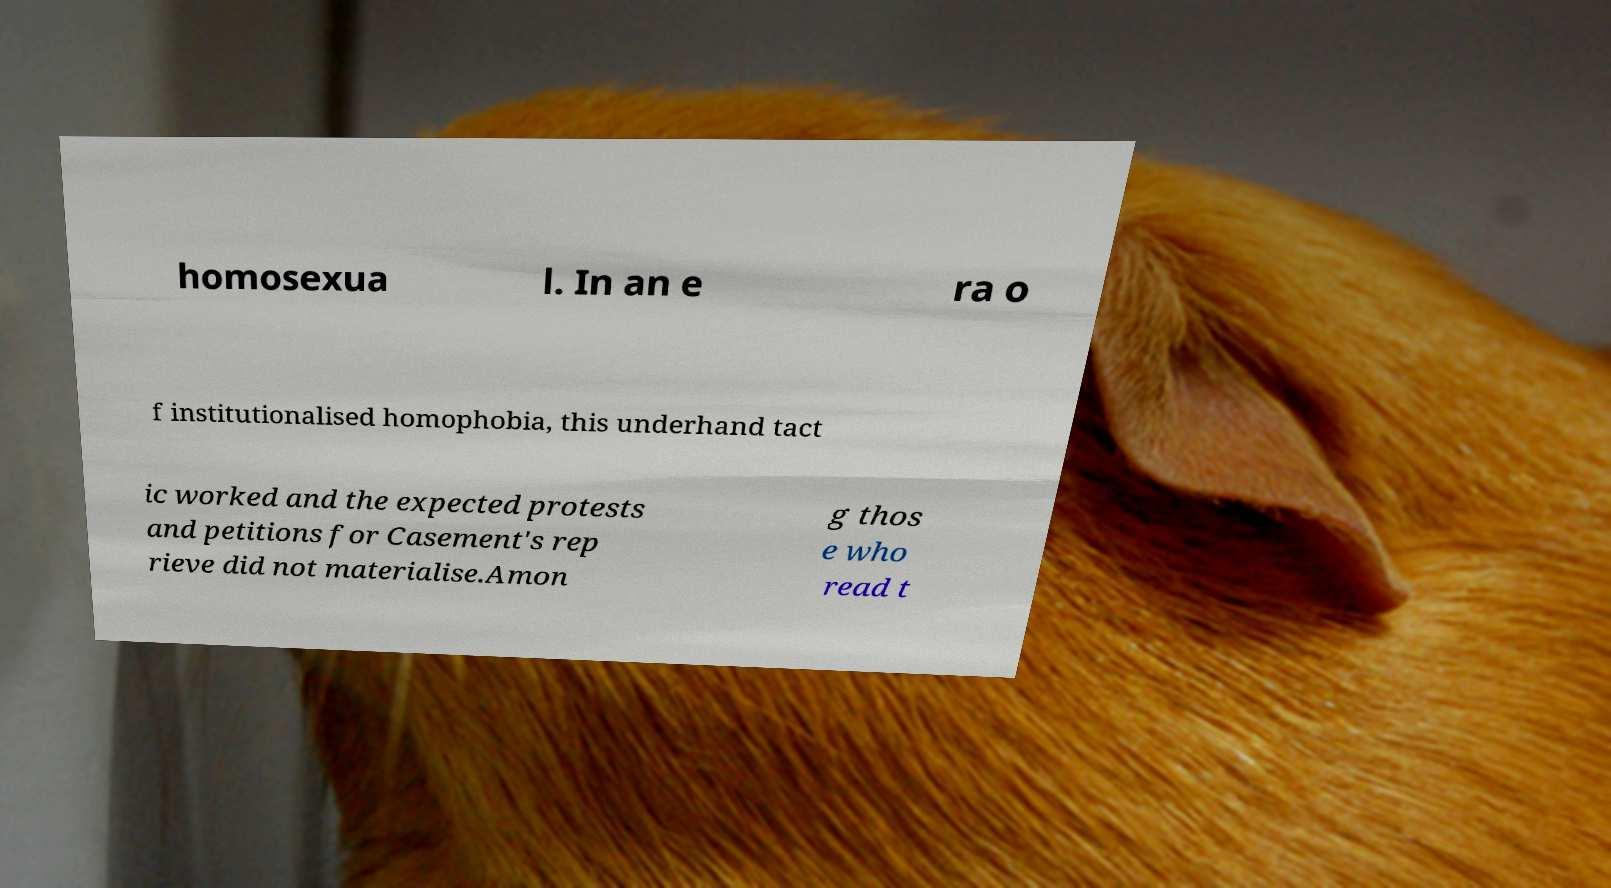Could you extract and type out the text from this image? homosexua l. In an e ra o f institutionalised homophobia, this underhand tact ic worked and the expected protests and petitions for Casement's rep rieve did not materialise.Amon g thos e who read t 